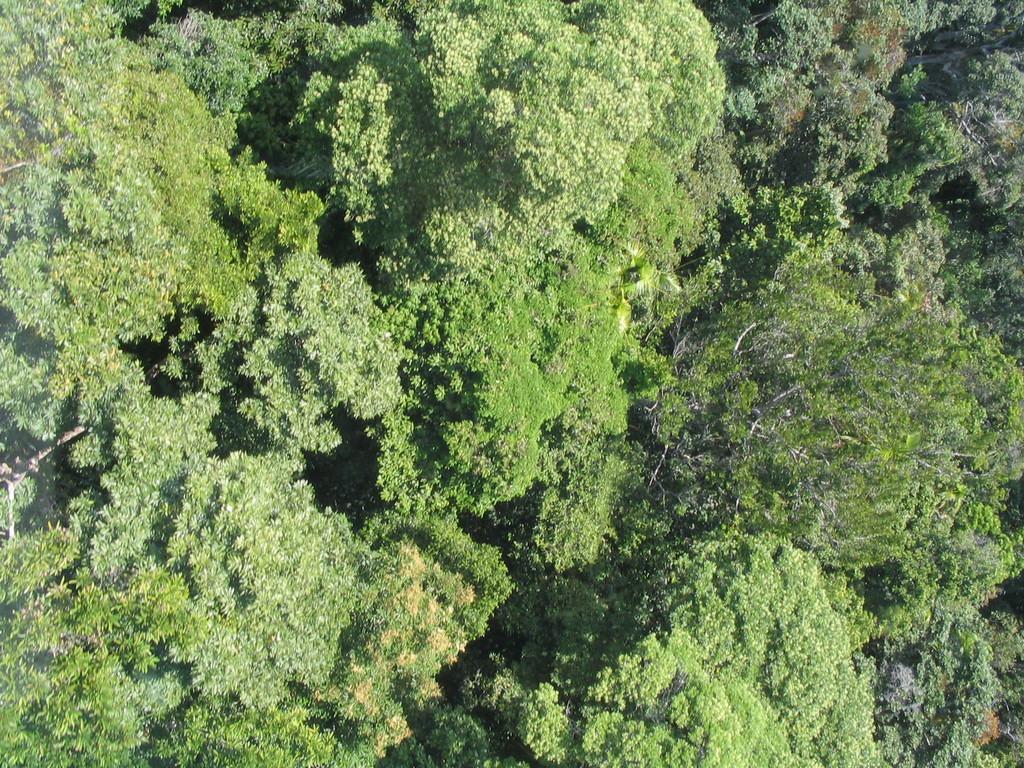Can you describe this image briefly? In this image we can see an outside view of a group of trees. 